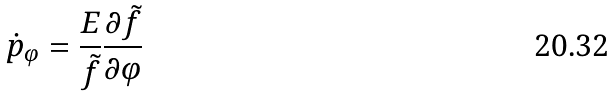Convert formula to latex. <formula><loc_0><loc_0><loc_500><loc_500>\dot { p } _ { \varphi } = \frac { E } { \tilde { f } } \frac { \partial \tilde { f } } { \partial \varphi }</formula> 